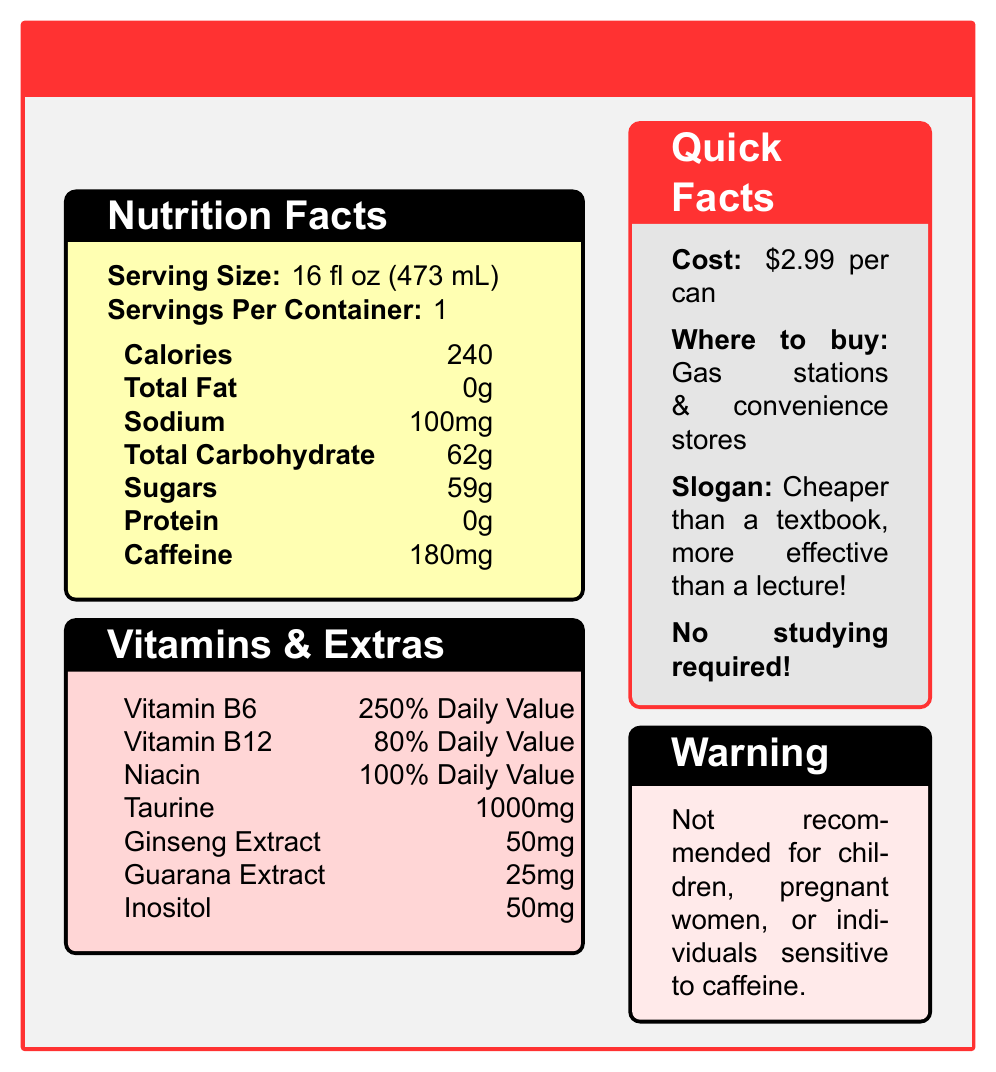what is the serving size of Thunder Bolt Energy Drink? The serving size is clearly listed as 16 fl oz (473 mL) in the Nutrition Facts section of the document.
Answer: 16 fl oz (473 mL) how many calories are in one serving? The document states that one serving contains 240 calories.
Answer: 240 what is the amount of caffeine in one can? The document specifies that there is 180mg of caffeine per serving, and since there is one serving per container, one can has 180mg of caffeine.
Answer: 180mg how much sugar is present in a can? According to the Nutrition Facts, each 16 fl oz serving, which is one can, contains 59g of sugar.
Answer: 59g what are the percentages of daily values for Vitamin B6 and Niacin? The Vitamins & Extras section lists Vitamin B6 at 250% Daily Value and Niacin at 100% Daily Value.
Answer: Vitamin B6: 250%, Niacin: 100% how many servings are in one container? The document specifies that there is 1 serving per container.
Answer: 1 what is the cost of one can? The Quick Facts section lists the cost as $2.99 per can.
Answer: $2.99 what is the slogan mentioned in the document? The Quick Facts section provides the slogan as "Cheaper than a textbook, more effective than a lecture!"
Answer: Cheaper than a textbook, more effective than a lecture! where can you purchase Thunder Bolt Energy Drink? A. Online Stores B. Gas Stations & Convenience Stores C. Supermarkets The document mentions that the drink is available at gas stations and convenience stores.
Answer: B how much sodium is in a single serving of the drink? A. 100mg B. 200mg C. 300mg The Nutrition Facts section lists the sodium content as 100mg.
Answer: A is this energy drink recommended for children? Yes/No The warning clearly states that it is not recommended for children, pregnant women, or individuals sensitive to caffeine.
Answer: No summarize the main idea of the document The document is a nutrition facts label for Thunder Bolt Energy Drink, emphasizing its energy-boosting properties, high caffeine and sugar content, various vitamins, and its marketing angle of being a budget-friendly alternative to traditional education resources.
Answer: Thunder Bolt Energy Drink provides nutritional information suggesting high caffeine and sugar content. It emphasizes a quick energy boost with added vitamins and ingredients like taurine, ginseng, and guarana. Sold at $2.99, it markets itself as inexpensive and easily accessible. what is the amount of taurine in the drink? The Vitamins & Extras section lists taurine as 1000mg.
Answer: 1000mg how much ginseng extract does the drink contain? According to the Vitamins & Extras section, the drink contains 50mg of ginseng extract.
Answer: 50mg what is the daily value percentage for Vitamin B12 provided by the drink? The amount of Vitamin B12 is mentioned as 80% of the Daily Value in the document.
Answer: 80% what is the amount of inositol in the drink? The Vitamins & Extras section shows that the drink contains 50mg of inositol.
Answer: 50mg does the document specify the carbohydrate type? The document lists total carbohydrates as 62g and sugars as 59g but does not specify the type of carbohydrates.
Answer: No which ingredient is present in the highest amount? A. Taurine B. Ginseng Extract C. Guarana Extract Taurine is listed as 1000mg, which is higher than both Ginseng Extract (50mg) and Guarana Extract (25mg).
Answer: A can the drink be considered caffeine-free? The document lists a caffeine content of 180mg, so it cannot be considered caffeine-free.
Answer: No 